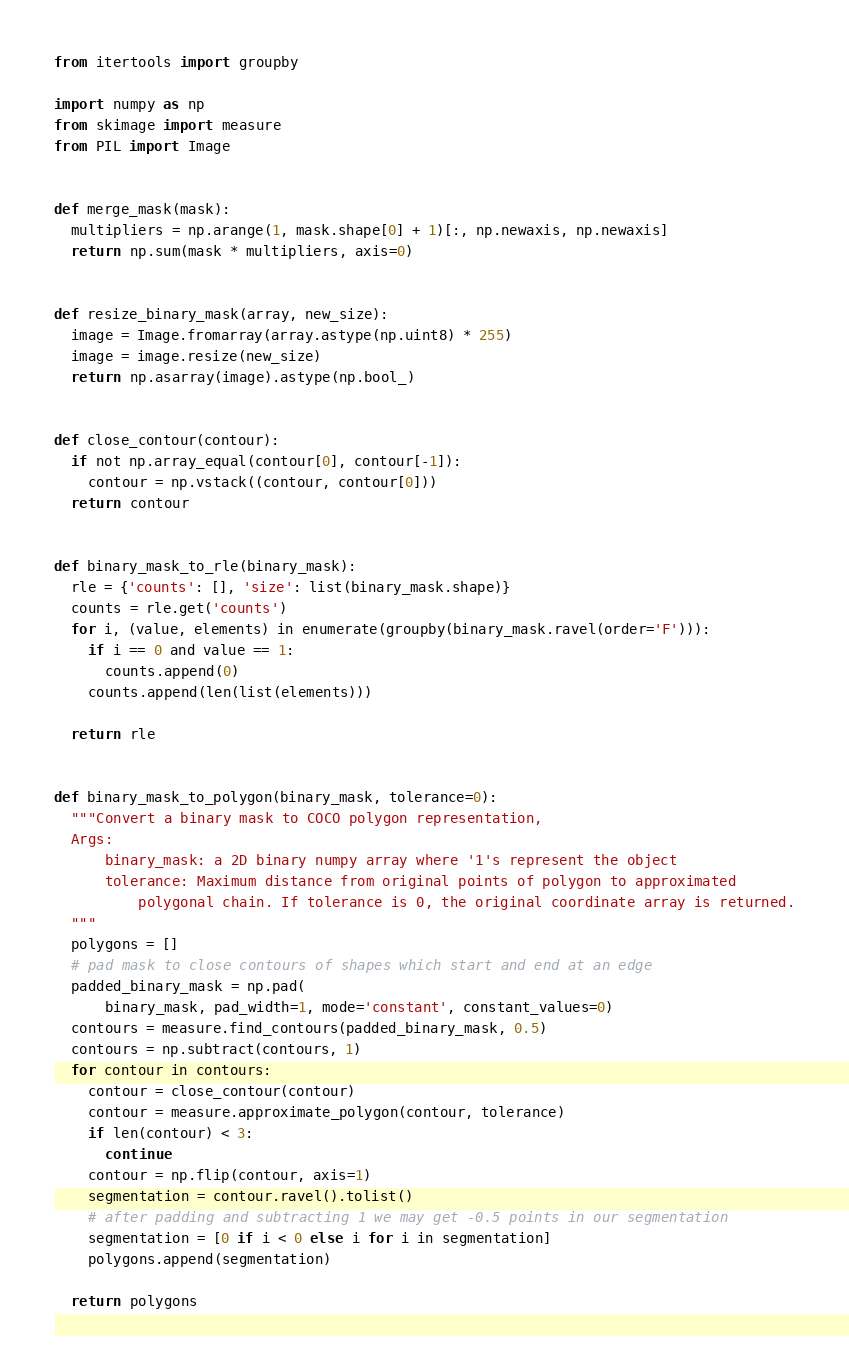<code> <loc_0><loc_0><loc_500><loc_500><_Python_>from itertools import groupby

import numpy as np
from skimage import measure
from PIL import Image


def merge_mask(mask):
  multipliers = np.arange(1, mask.shape[0] + 1)[:, np.newaxis, np.newaxis]
  return np.sum(mask * multipliers, axis=0)


def resize_binary_mask(array, new_size):
  image = Image.fromarray(array.astype(np.uint8) * 255)
  image = image.resize(new_size)
  return np.asarray(image).astype(np.bool_)


def close_contour(contour):
  if not np.array_equal(contour[0], contour[-1]):
    contour = np.vstack((contour, contour[0]))
  return contour


def binary_mask_to_rle(binary_mask):
  rle = {'counts': [], 'size': list(binary_mask.shape)}
  counts = rle.get('counts')
  for i, (value, elements) in enumerate(groupby(binary_mask.ravel(order='F'))):
    if i == 0 and value == 1:
      counts.append(0)
    counts.append(len(list(elements)))

  return rle


def binary_mask_to_polygon(binary_mask, tolerance=0):
  """Convert a binary mask to COCO polygon representation,
  Args:
      binary_mask: a 2D binary numpy array where '1's represent the object
      tolerance: Maximum distance from original points of polygon to approximated
          polygonal chain. If tolerance is 0, the original coordinate array is returned.
  """
  polygons = []
  # pad mask to close contours of shapes which start and end at an edge
  padded_binary_mask = np.pad(
      binary_mask, pad_width=1, mode='constant', constant_values=0)
  contours = measure.find_contours(padded_binary_mask, 0.5)
  contours = np.subtract(contours, 1)
  for contour in contours:
    contour = close_contour(contour)
    contour = measure.approximate_polygon(contour, tolerance)
    if len(contour) < 3:
      continue
    contour = np.flip(contour, axis=1)
    segmentation = contour.ravel().tolist()
    # after padding and subtracting 1 we may get -0.5 points in our segmentation
    segmentation = [0 if i < 0 else i for i in segmentation]
    polygons.append(segmentation)

  return polygons
</code> 